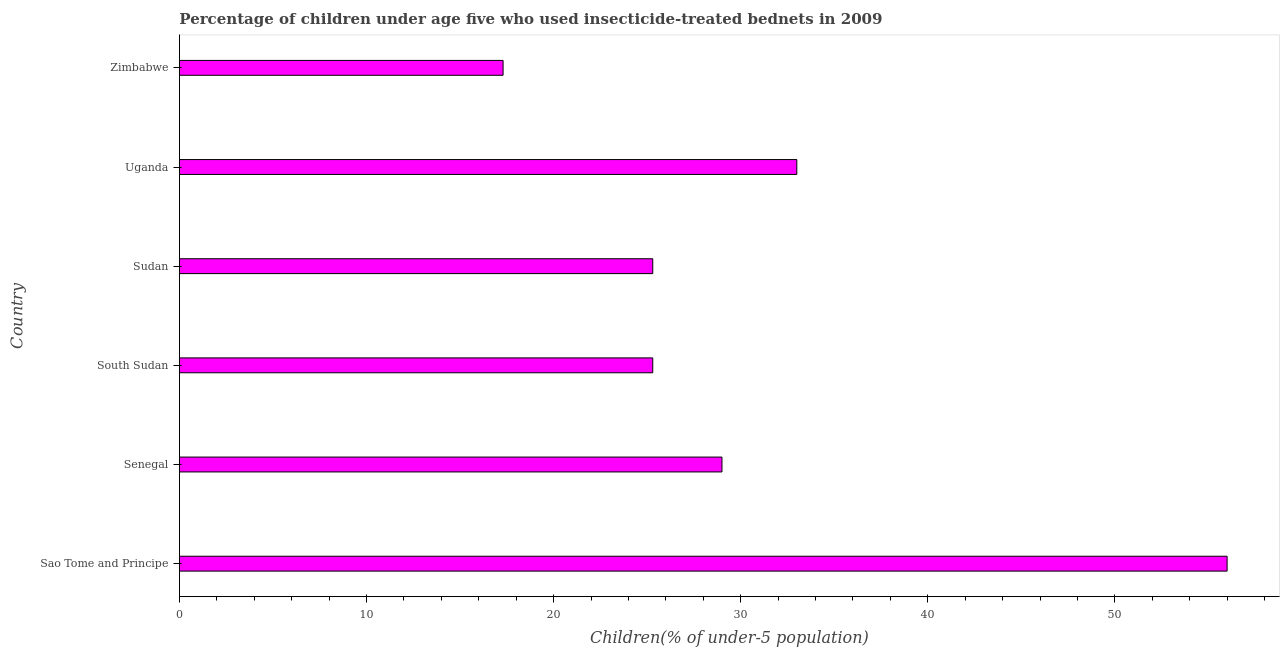Does the graph contain grids?
Your answer should be compact. No. What is the title of the graph?
Keep it short and to the point. Percentage of children under age five who used insecticide-treated bednets in 2009. What is the label or title of the X-axis?
Provide a short and direct response. Children(% of under-5 population). Across all countries, what is the minimum percentage of children who use of insecticide-treated bed nets?
Make the answer very short. 17.3. In which country was the percentage of children who use of insecticide-treated bed nets maximum?
Offer a very short reply. Sao Tome and Principe. In which country was the percentage of children who use of insecticide-treated bed nets minimum?
Make the answer very short. Zimbabwe. What is the sum of the percentage of children who use of insecticide-treated bed nets?
Offer a terse response. 185.9. What is the difference between the percentage of children who use of insecticide-treated bed nets in Senegal and Zimbabwe?
Your response must be concise. 11.7. What is the average percentage of children who use of insecticide-treated bed nets per country?
Provide a succinct answer. 30.98. What is the median percentage of children who use of insecticide-treated bed nets?
Provide a succinct answer. 27.15. In how many countries, is the percentage of children who use of insecticide-treated bed nets greater than 18 %?
Your answer should be compact. 5. What is the ratio of the percentage of children who use of insecticide-treated bed nets in Senegal to that in Uganda?
Offer a very short reply. 0.88. Is the percentage of children who use of insecticide-treated bed nets in Sudan less than that in Uganda?
Your response must be concise. Yes. Is the difference between the percentage of children who use of insecticide-treated bed nets in Sao Tome and Principe and Senegal greater than the difference between any two countries?
Your answer should be very brief. No. What is the difference between the highest and the second highest percentage of children who use of insecticide-treated bed nets?
Your answer should be compact. 23. What is the difference between the highest and the lowest percentage of children who use of insecticide-treated bed nets?
Ensure brevity in your answer.  38.7. How many bars are there?
Give a very brief answer. 6. What is the difference between two consecutive major ticks on the X-axis?
Your answer should be compact. 10. What is the Children(% of under-5 population) of Sao Tome and Principe?
Give a very brief answer. 56. What is the Children(% of under-5 population) in Senegal?
Make the answer very short. 29. What is the Children(% of under-5 population) of South Sudan?
Make the answer very short. 25.3. What is the Children(% of under-5 population) of Sudan?
Your answer should be very brief. 25.3. What is the Children(% of under-5 population) of Uganda?
Give a very brief answer. 33. What is the Children(% of under-5 population) of Zimbabwe?
Provide a short and direct response. 17.3. What is the difference between the Children(% of under-5 population) in Sao Tome and Principe and South Sudan?
Offer a terse response. 30.7. What is the difference between the Children(% of under-5 population) in Sao Tome and Principe and Sudan?
Offer a very short reply. 30.7. What is the difference between the Children(% of under-5 population) in Sao Tome and Principe and Zimbabwe?
Offer a very short reply. 38.7. What is the difference between the Children(% of under-5 population) in Senegal and South Sudan?
Make the answer very short. 3.7. What is the difference between the Children(% of under-5 population) in Senegal and Sudan?
Keep it short and to the point. 3.7. What is the difference between the Children(% of under-5 population) in Senegal and Uganda?
Keep it short and to the point. -4. What is the difference between the Children(% of under-5 population) in Senegal and Zimbabwe?
Your response must be concise. 11.7. What is the difference between the Children(% of under-5 population) in South Sudan and Sudan?
Provide a short and direct response. 0. What is the difference between the Children(% of under-5 population) in Sudan and Zimbabwe?
Keep it short and to the point. 8. What is the ratio of the Children(% of under-5 population) in Sao Tome and Principe to that in Senegal?
Make the answer very short. 1.93. What is the ratio of the Children(% of under-5 population) in Sao Tome and Principe to that in South Sudan?
Your answer should be very brief. 2.21. What is the ratio of the Children(% of under-5 population) in Sao Tome and Principe to that in Sudan?
Keep it short and to the point. 2.21. What is the ratio of the Children(% of under-5 population) in Sao Tome and Principe to that in Uganda?
Provide a short and direct response. 1.7. What is the ratio of the Children(% of under-5 population) in Sao Tome and Principe to that in Zimbabwe?
Your response must be concise. 3.24. What is the ratio of the Children(% of under-5 population) in Senegal to that in South Sudan?
Ensure brevity in your answer.  1.15. What is the ratio of the Children(% of under-5 population) in Senegal to that in Sudan?
Make the answer very short. 1.15. What is the ratio of the Children(% of under-5 population) in Senegal to that in Uganda?
Keep it short and to the point. 0.88. What is the ratio of the Children(% of under-5 population) in Senegal to that in Zimbabwe?
Your response must be concise. 1.68. What is the ratio of the Children(% of under-5 population) in South Sudan to that in Uganda?
Your response must be concise. 0.77. What is the ratio of the Children(% of under-5 population) in South Sudan to that in Zimbabwe?
Offer a very short reply. 1.46. What is the ratio of the Children(% of under-5 population) in Sudan to that in Uganda?
Keep it short and to the point. 0.77. What is the ratio of the Children(% of under-5 population) in Sudan to that in Zimbabwe?
Provide a succinct answer. 1.46. What is the ratio of the Children(% of under-5 population) in Uganda to that in Zimbabwe?
Keep it short and to the point. 1.91. 